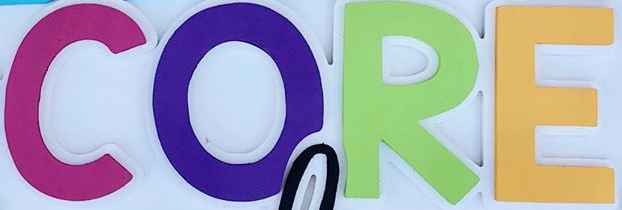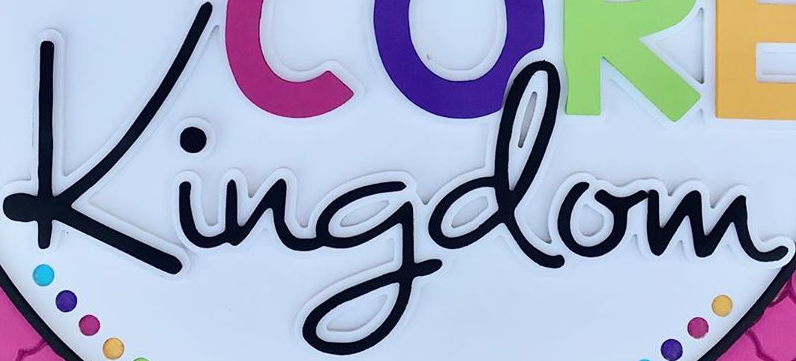What text appears in these images from left to right, separated by a semicolon? CORE; Kingdom 